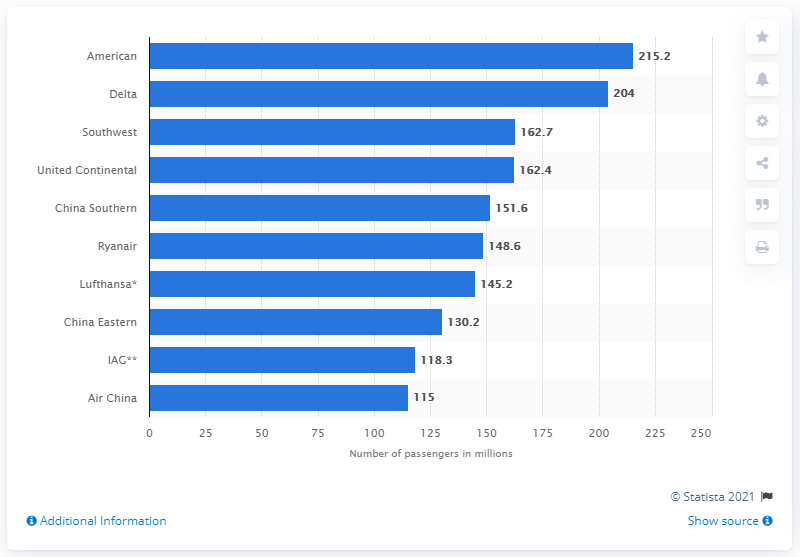Specify some key components in this picture. In 2019, American Airlines carried a total of 215,200 passengers. 